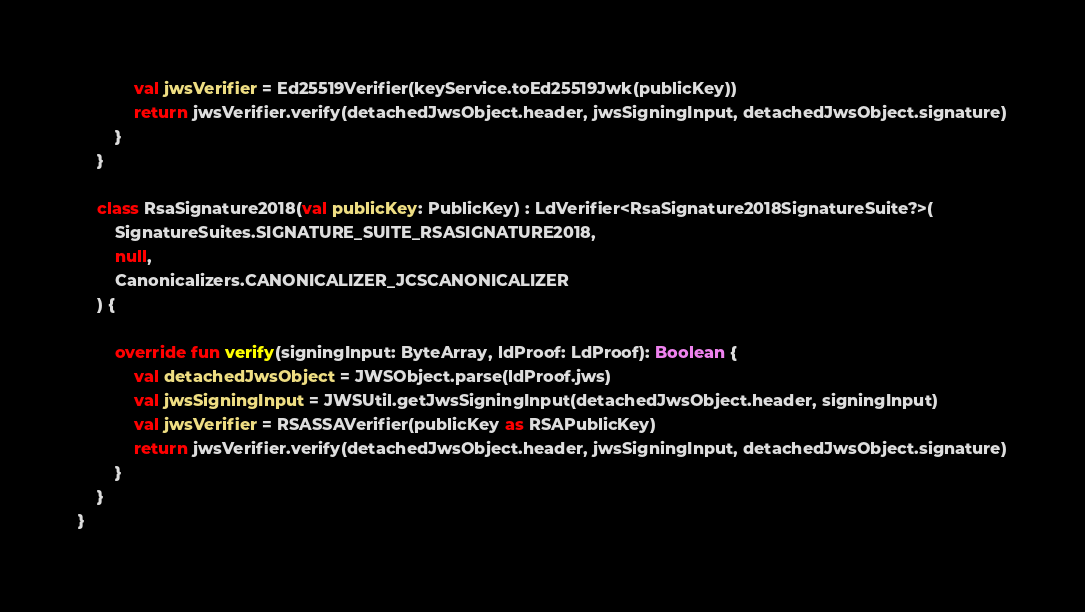<code> <loc_0><loc_0><loc_500><loc_500><_Kotlin_>            val jwsVerifier = Ed25519Verifier(keyService.toEd25519Jwk(publicKey))
            return jwsVerifier.verify(detachedJwsObject.header, jwsSigningInput, detachedJwsObject.signature)
        }
    }

    class RsaSignature2018(val publicKey: PublicKey) : LdVerifier<RsaSignature2018SignatureSuite?>(
        SignatureSuites.SIGNATURE_SUITE_RSASIGNATURE2018,
        null,
        Canonicalizers.CANONICALIZER_JCSCANONICALIZER
    ) {

        override fun verify(signingInput: ByteArray, ldProof: LdProof): Boolean {
            val detachedJwsObject = JWSObject.parse(ldProof.jws)
            val jwsSigningInput = JWSUtil.getJwsSigningInput(detachedJwsObject.header, signingInput)
            val jwsVerifier = RSASSAVerifier(publicKey as RSAPublicKey)
            return jwsVerifier.verify(detachedJwsObject.header, jwsSigningInput, detachedJwsObject.signature)
        }
    }
}
</code> 